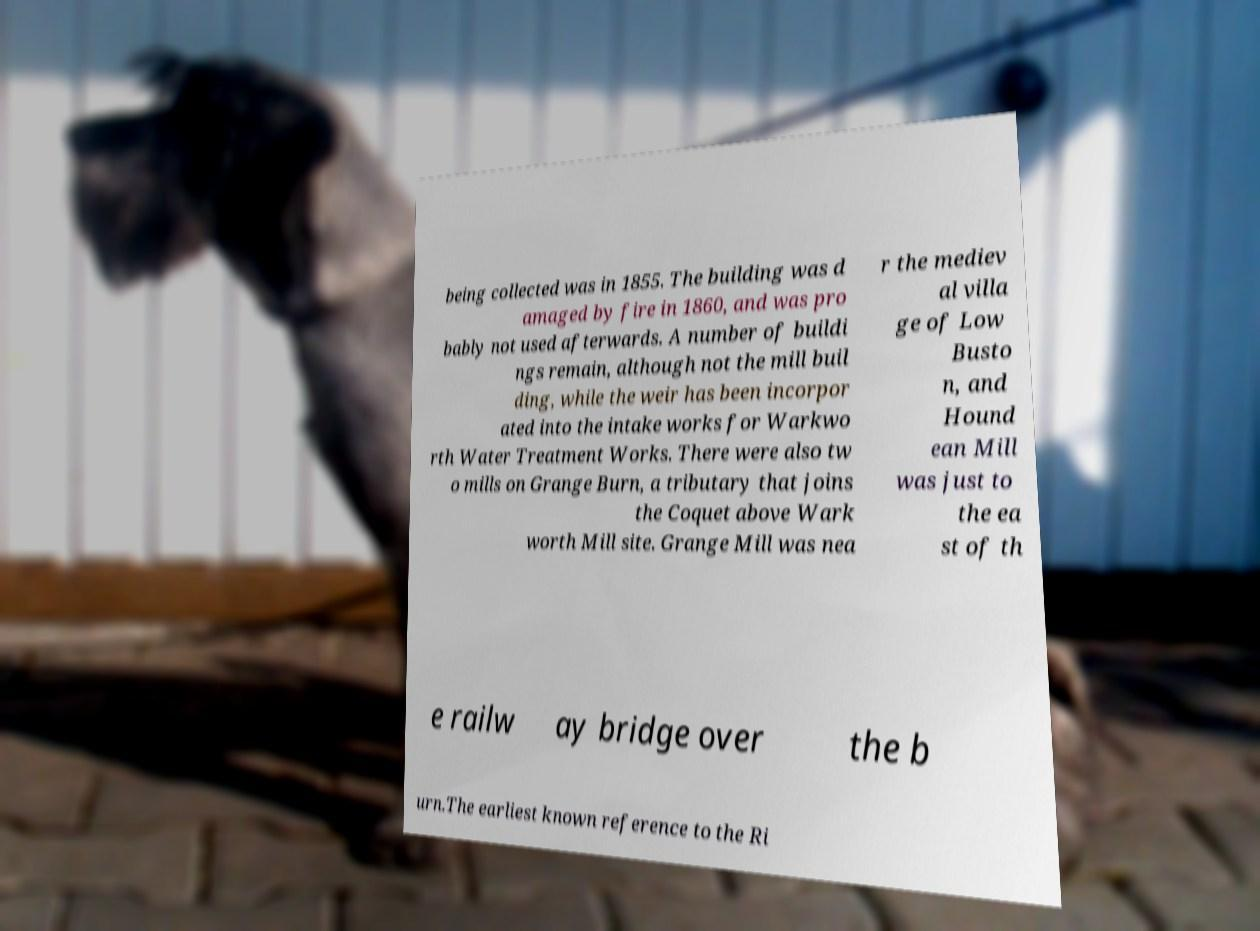Can you read and provide the text displayed in the image?This photo seems to have some interesting text. Can you extract and type it out for me? being collected was in 1855. The building was d amaged by fire in 1860, and was pro bably not used afterwards. A number of buildi ngs remain, although not the mill buil ding, while the weir has been incorpor ated into the intake works for Warkwo rth Water Treatment Works. There were also tw o mills on Grange Burn, a tributary that joins the Coquet above Wark worth Mill site. Grange Mill was nea r the mediev al villa ge of Low Busto n, and Hound ean Mill was just to the ea st of th e railw ay bridge over the b urn.The earliest known reference to the Ri 